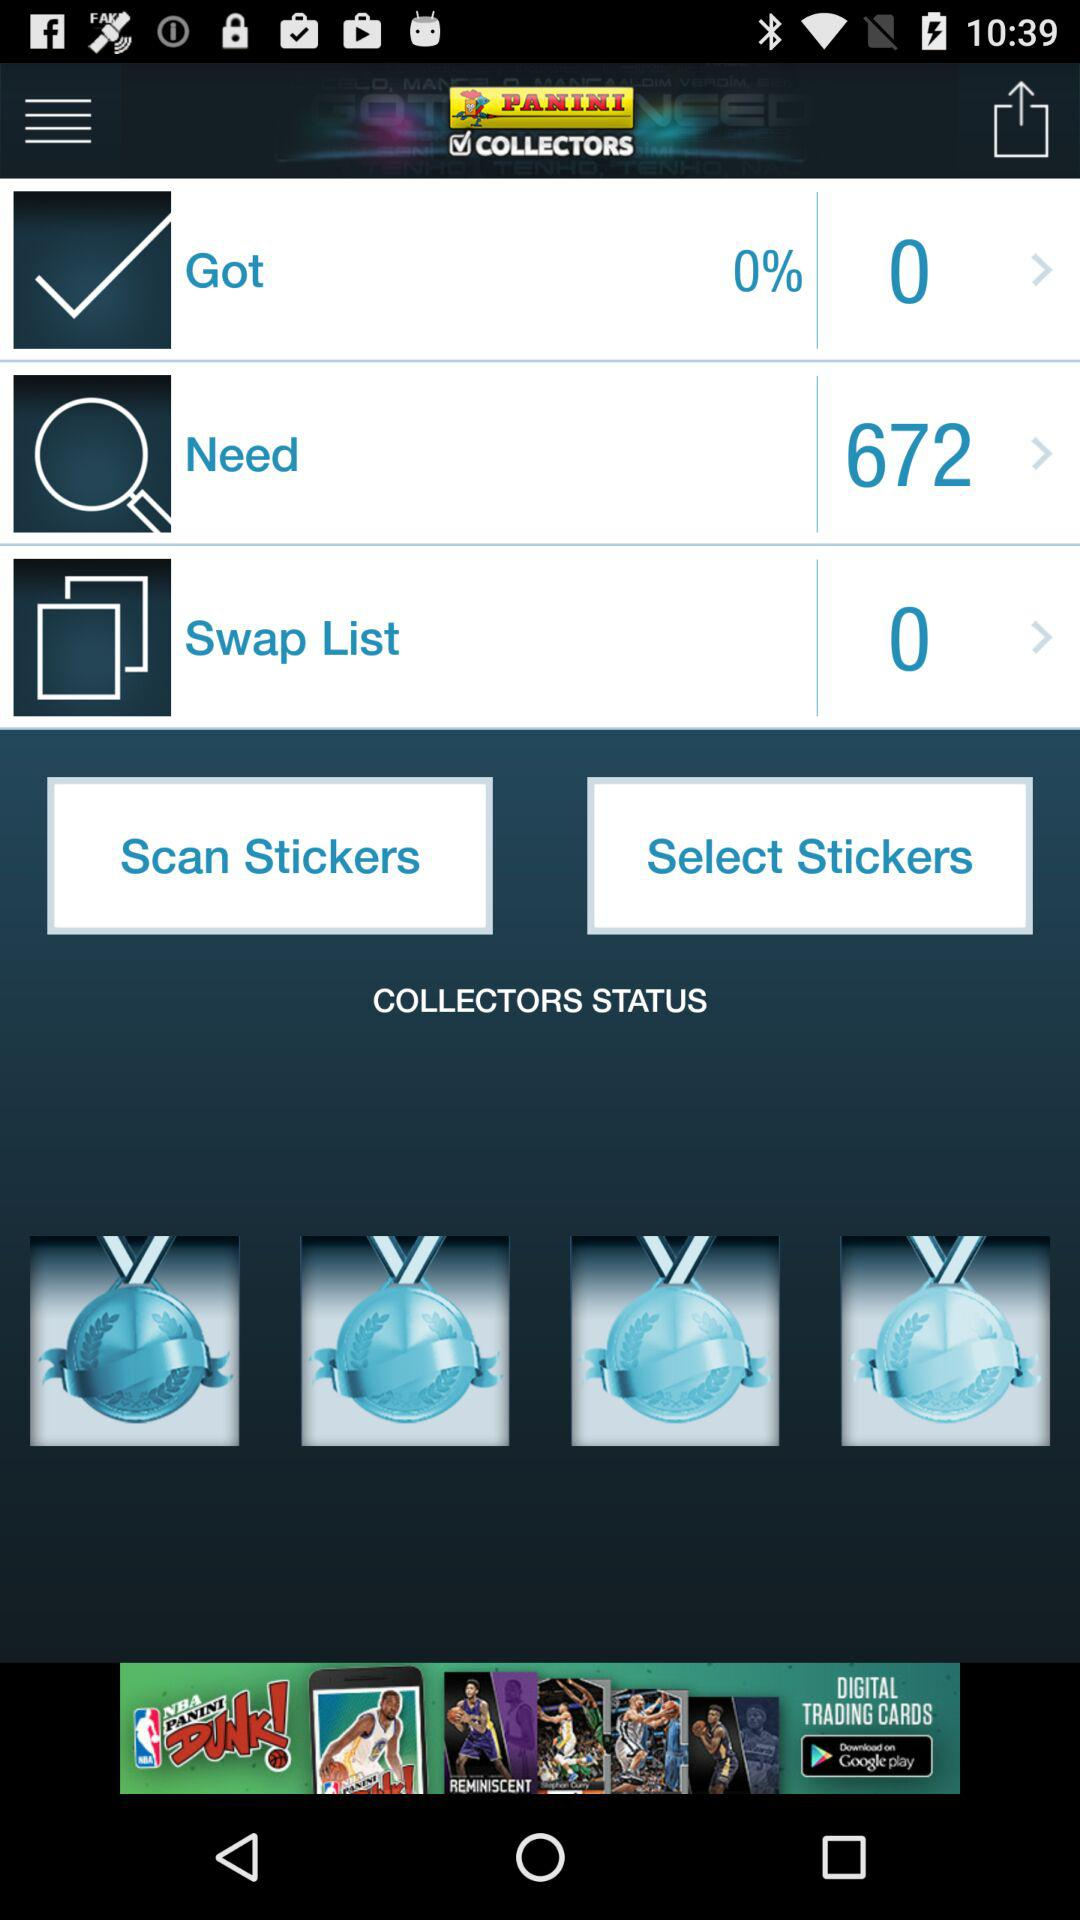What is the number of swap lists shown in the application? The number of swap lists shown in the application is 0. 